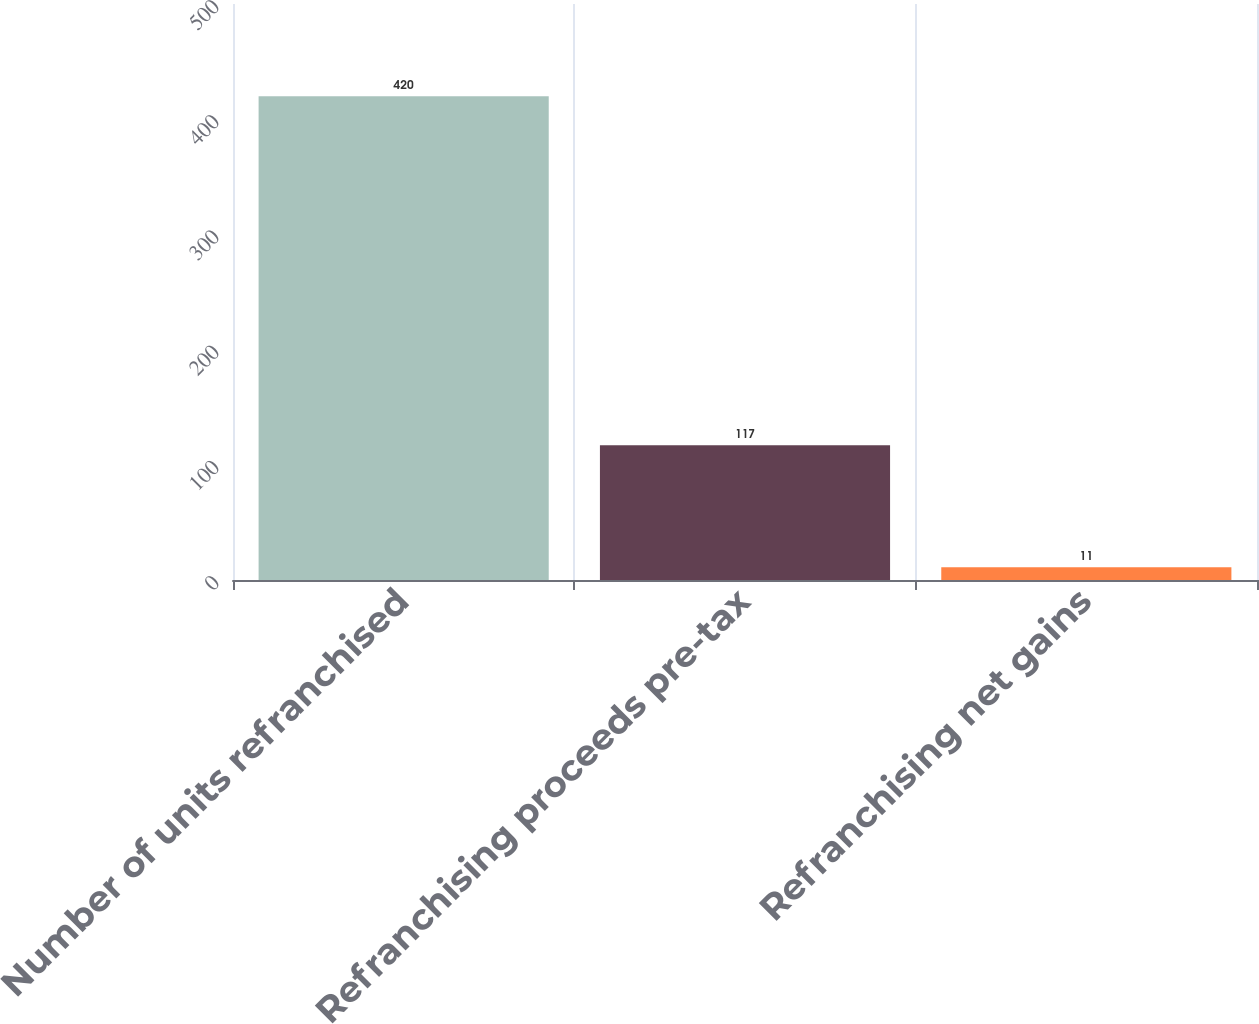Convert chart to OTSL. <chart><loc_0><loc_0><loc_500><loc_500><bar_chart><fcel>Number of units refranchised<fcel>Refranchising proceeds pre-tax<fcel>Refranchising net gains<nl><fcel>420<fcel>117<fcel>11<nl></chart> 